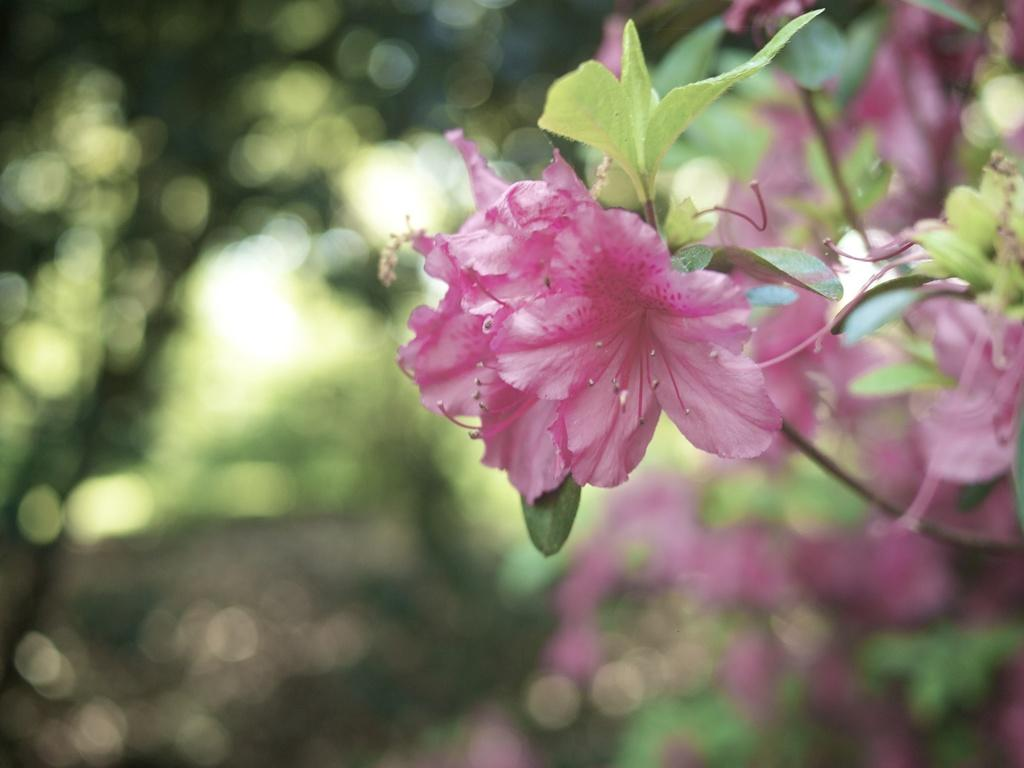What type of flowers can be seen in the image? There are pink color flowers in the image. What else is present along with the flowers? There are leaves in the image. Can you describe the plant visible in the background? There is a plant visible in the background of the image. What type of soup is being served in the image? There is no soup present in the image; it features pink color flowers, leaves, and a plant in the background. 